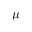Convert formula to latex. <formula><loc_0><loc_0><loc_500><loc_500>\mu</formula> 